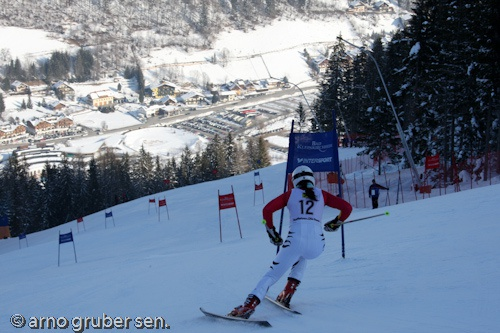Describe the objects in this image and their specific colors. I can see people in darkgray, gray, and black tones, skis in darkgray, gray, blue, and navy tones, people in darkgray, black, navy, gray, and darkblue tones, car in darkgray, gray, lightgray, and beige tones, and car in darkgray, gray, and lightgray tones in this image. 